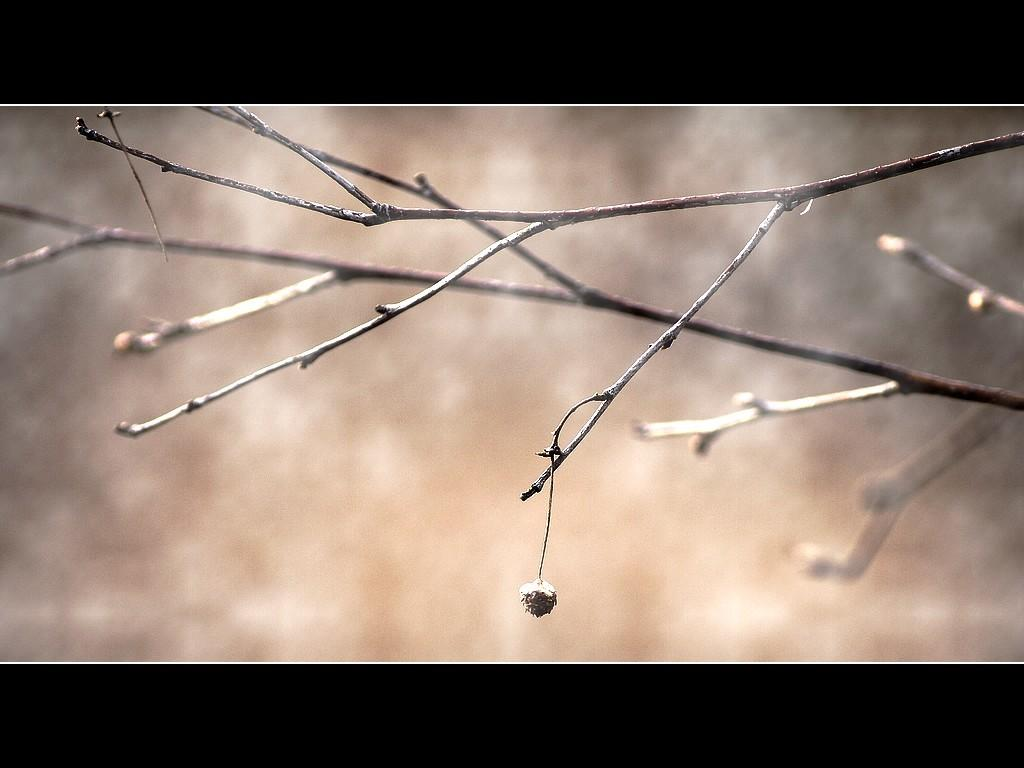What can be seen in the image that resembles plant parts? There are stems in the image. What type of scent can be detected from the stems in the image? There is no information about the scent of the stems in the image, as only their visual appearance is mentioned. 